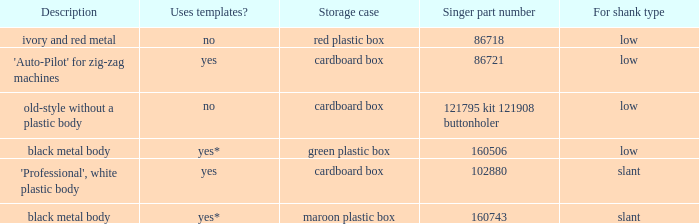What are all the different descriptions for the buttonholer with cardboard box for storage and a low shank type? 'Auto-Pilot' for zig-zag machines, old-style without a plastic body. 